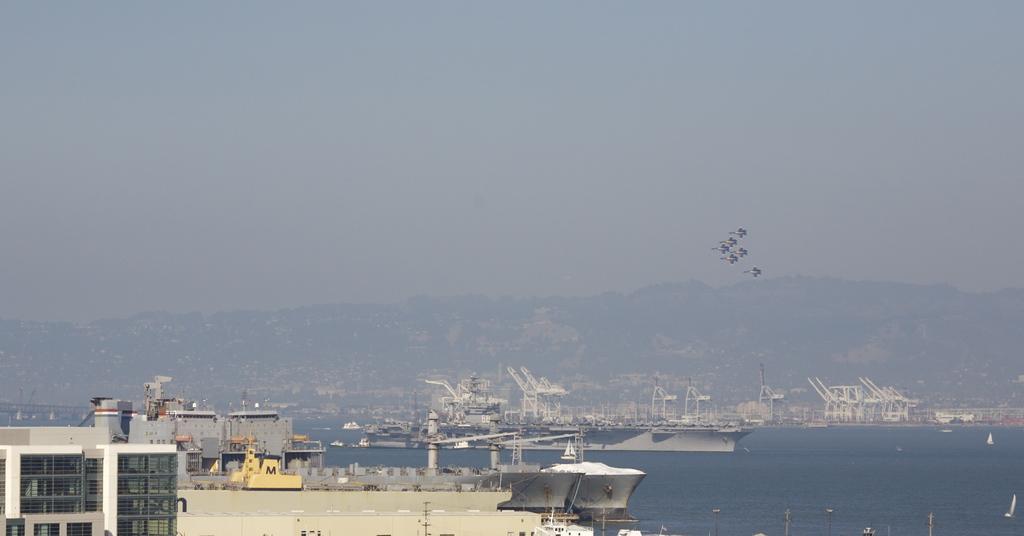Could you give a brief overview of what you see in this image? There are ships and boats on the water. Here we can see a building and there are birds flying in the air. In the background we can see a mountain and sky. 